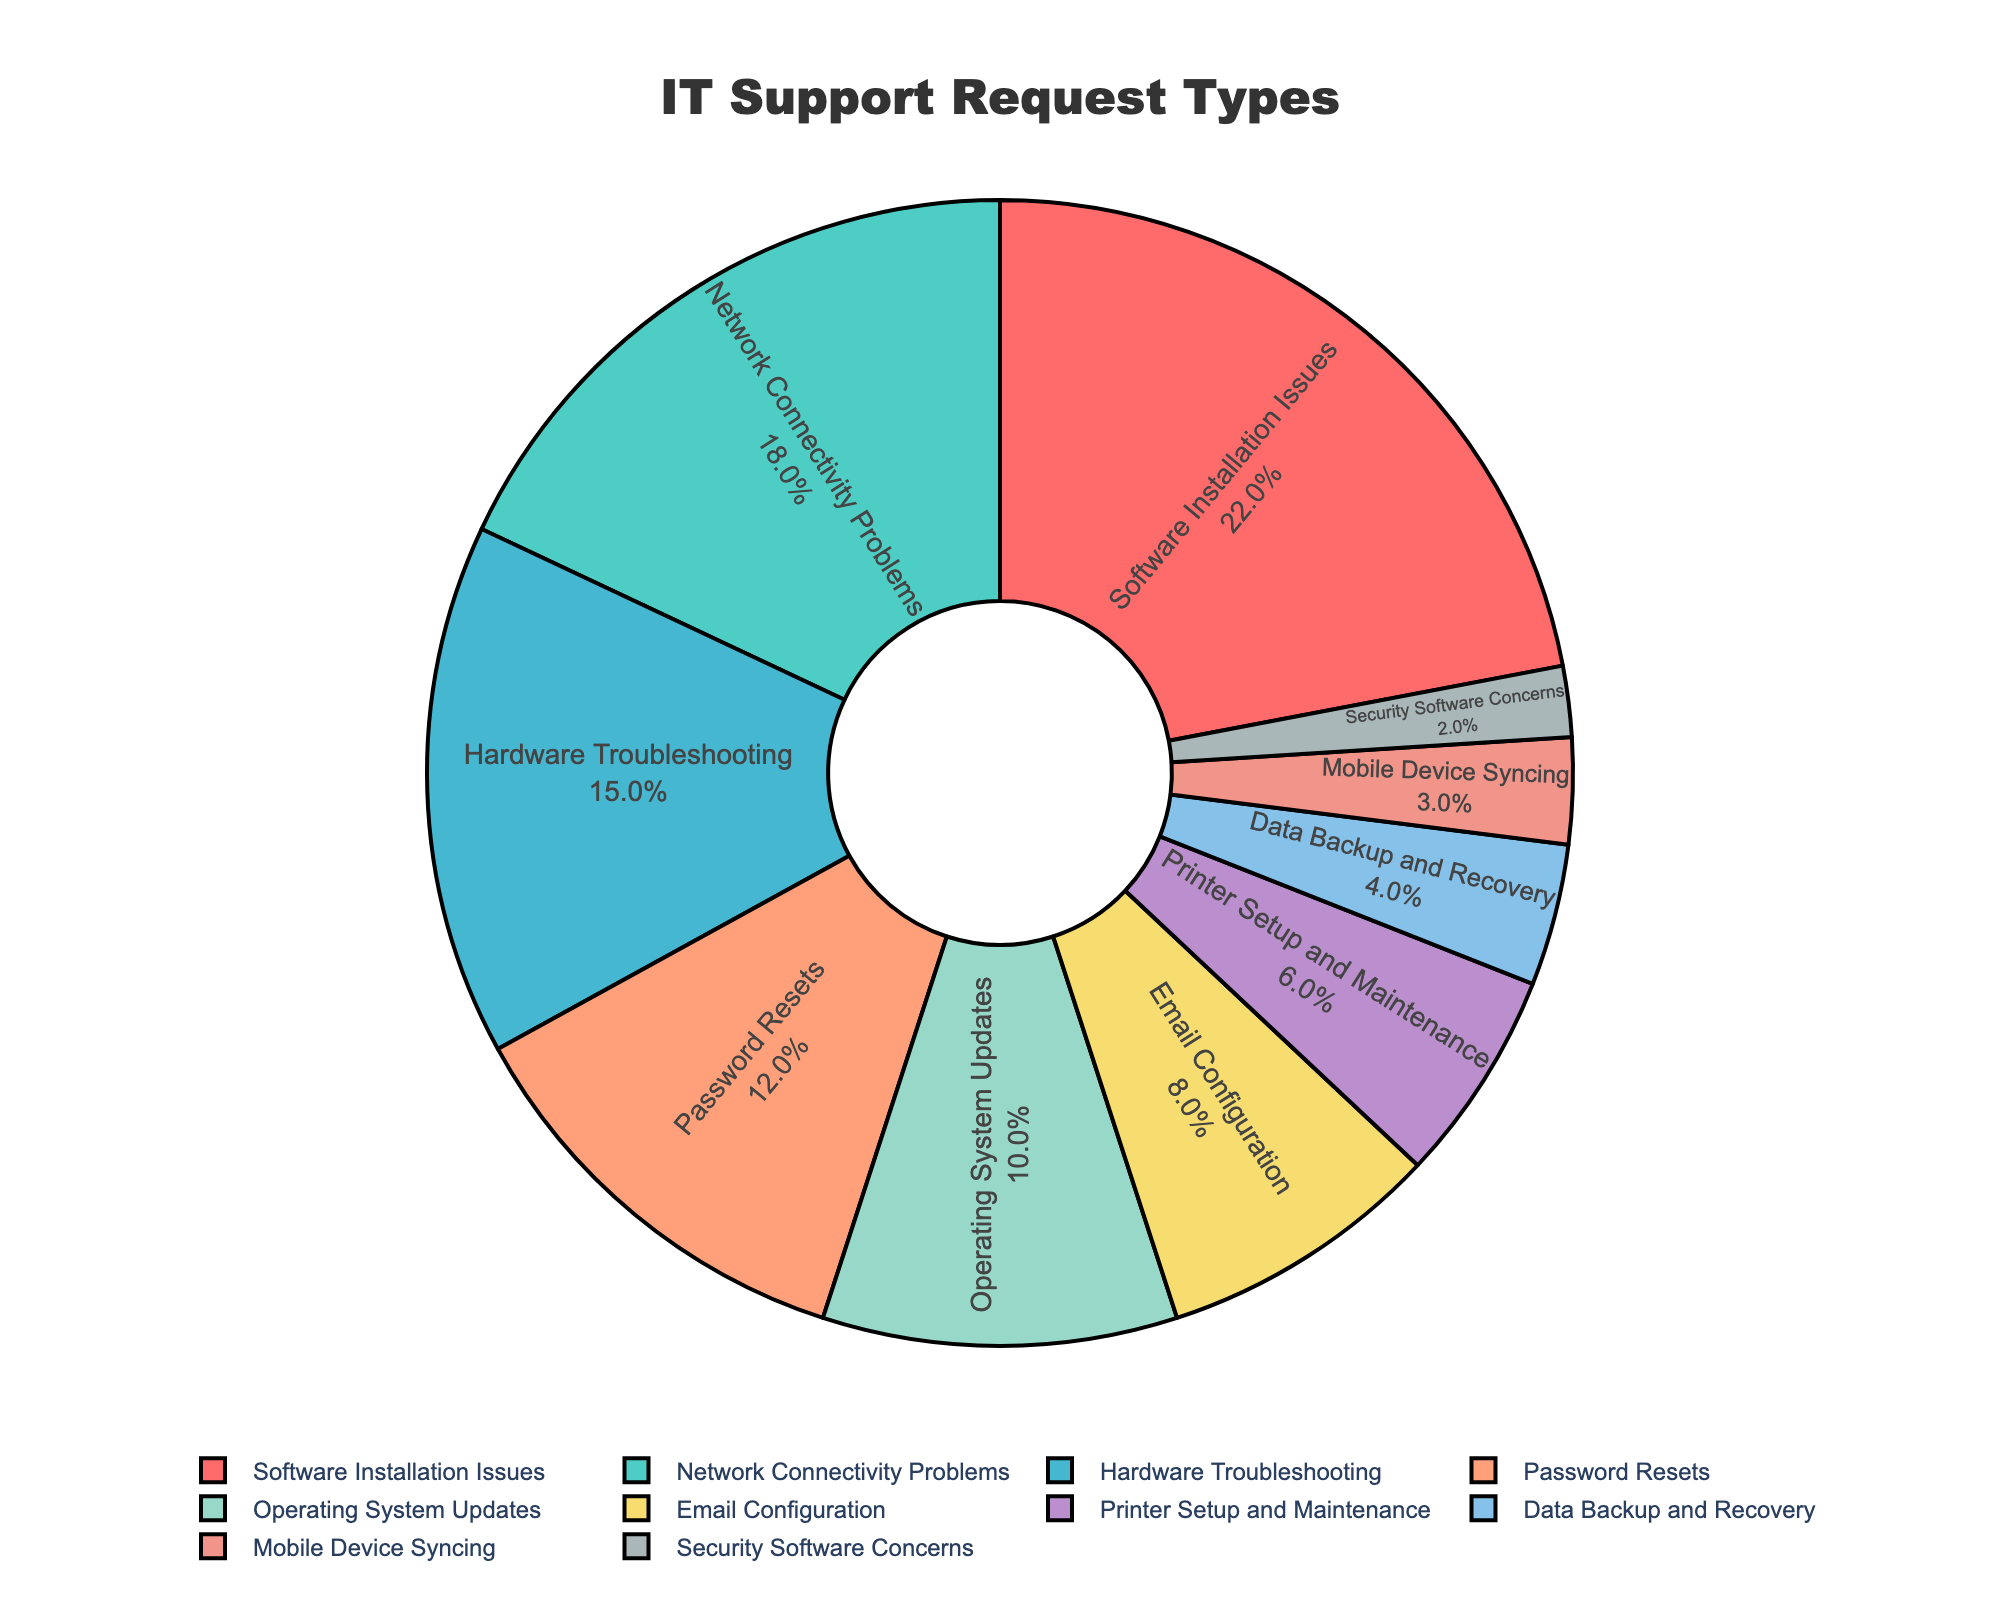Which type of technical support request is the most common? The pie chart labels and percentages reveal that "Software Installation Issues" has the largest percentage.
Answer: Software Installation Issues Which type of request is least common? By examining the smallest sector of the pie chart, "Security Software Concerns" has the smallest percentage.
Answer: Security Software Concerns What is the combined percentage of "Password Resets" and "Operating System Updates"? Add the percentages for "Password Resets" (12%) and "Operating System Updates" (10%), yielding 12% + 10% = 22%.
Answer: 22% How does the proportion of "Network Connectivity Problems" compare to that of "Hardware Troubleshooting"? "Network Connectivity Problems" (18%) is more common than "Hardware Troubleshooting" (15%).
Answer: Network Connectivity Problems is more common Which request types have a smaller percentage than "Email Configuration"? Examine the sectors with values less than 8%. These are: "Printer Setup and Maintenance" (6%), "Data Backup and Recovery" (4%), "Mobile Device Syncing" (3%), "Security Software Concerns" (2%).
Answer: Printer Setup and Maintenance, Data Backup and Recovery, Mobile Device Syncing, Security Software Concerns What is the total percentage of requests related to device issues (Printer Setup and Maintenance, Mobile Device Syncing, Hardware Troubleshooting)? Add the percentages: "Printer Setup and Maintenance" (6%), "Mobile Device Syncing" (3%), and "Hardware Troubleshooting" (15%). 6% + 3% + 15% = 24%.
Answer: 24% How much larger is the percentage of "Software Installation Issues" compared to "Email Configuration"? Subtract the percentage of "Email Configuration" (8%) from "Software Installation Issues" (22%): 22% - 8% = 14%.
Answer: 14% What percentage of the requests are related to network and connectivity issues (Network Connectivity Problems, Mobile Device Syncing)? Add the percentages for "Network Connectivity Problems" (18%) and "Mobile Device Syncing" (3%): 18% + 3% = 21%.
Answer: 21% Among "Operating System Updates" and "Password Resets", which is more frequent and by what percentage? Compare their percentages: "Password Resets" (12%) and "Operating System Updates" (10%). Subtract 10% from 12%: 12% - 10% = 2%.
Answer: Password Resets by 2% 